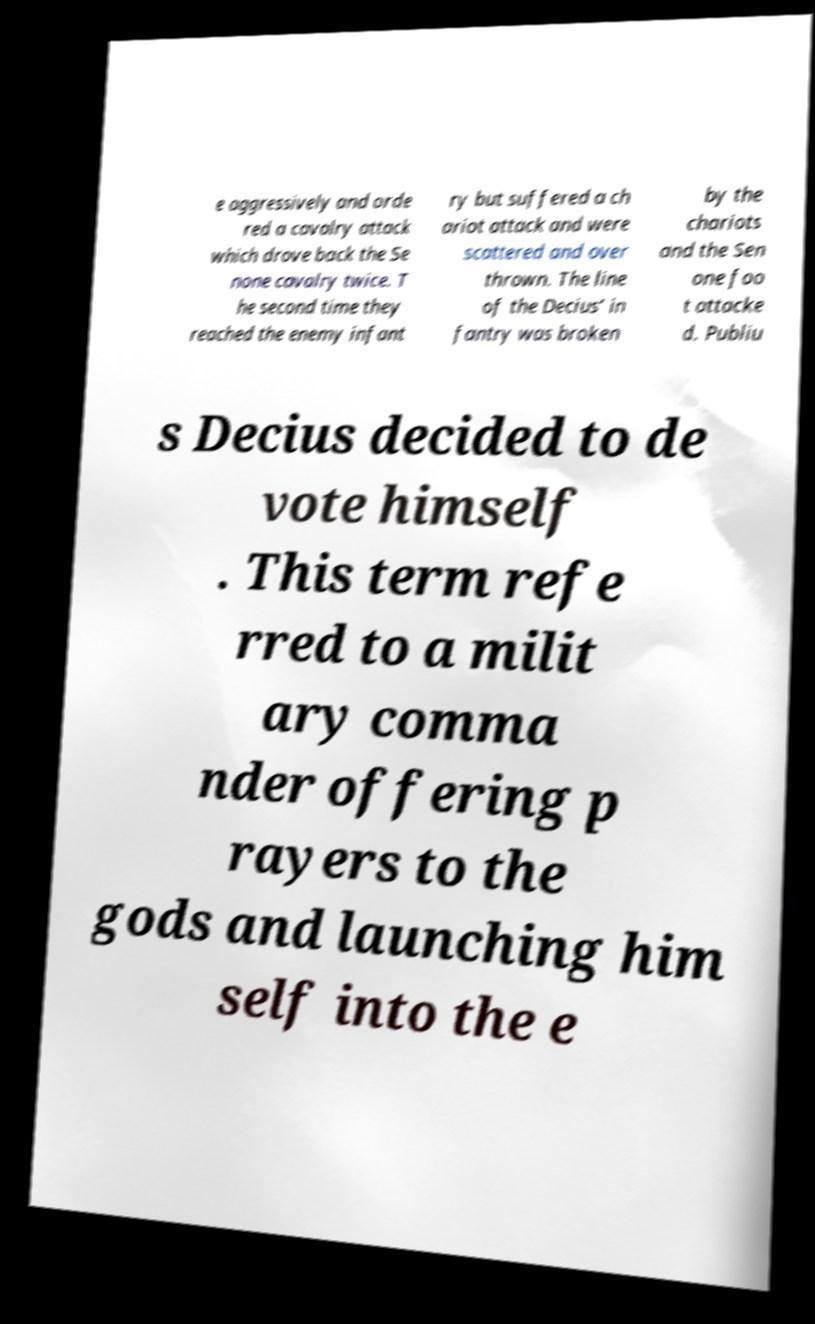There's text embedded in this image that I need extracted. Can you transcribe it verbatim? e aggressively and orde red a cavalry attack which drove back the Se none cavalry twice. T he second time they reached the enemy infant ry but suffered a ch ariot attack and were scattered and over thrown. The line of the Decius’ in fantry was broken by the chariots and the Sen one foo t attacke d. Publiu s Decius decided to de vote himself . This term refe rred to a milit ary comma nder offering p rayers to the gods and launching him self into the e 